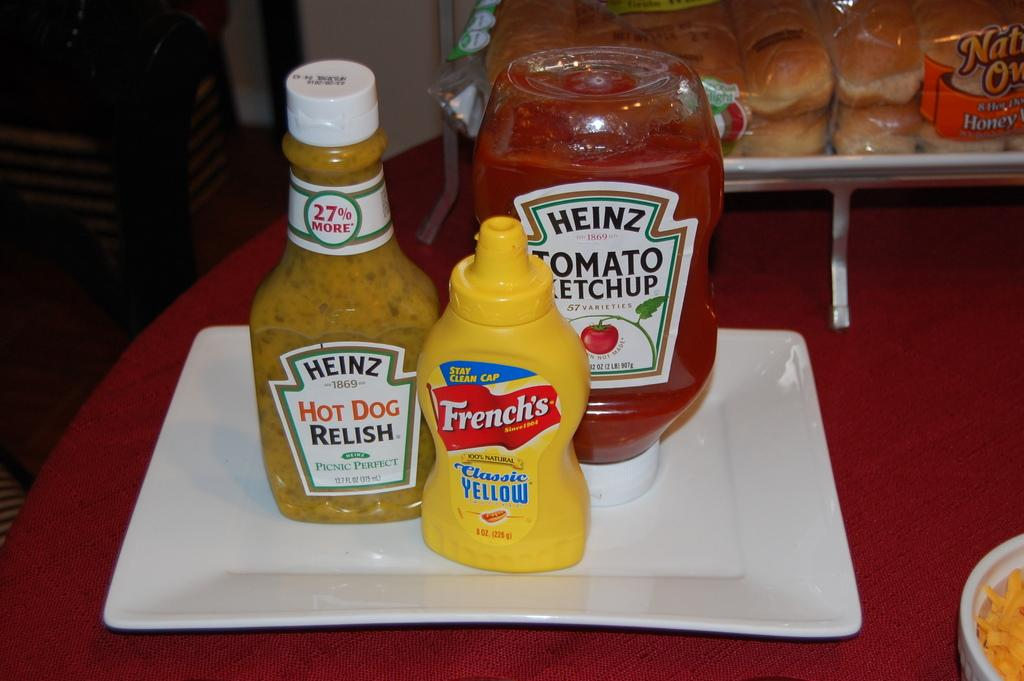Provide a one-sentence caption for the provided image. Bottles of Heinz relish and ketchup with a bottle of French's classic yellow mustard are on a plate. 